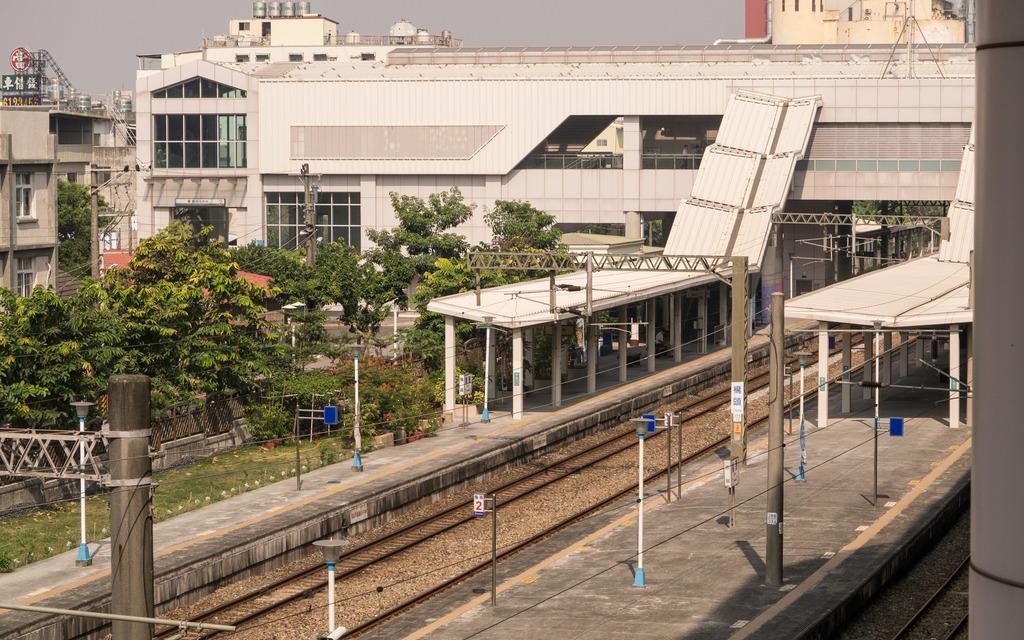Can you describe this image briefly? In this image there is a railway platform at bottom of this image and there are some trees at left side of this image and there are some buildings in the background and there is a sky at top of this image. 